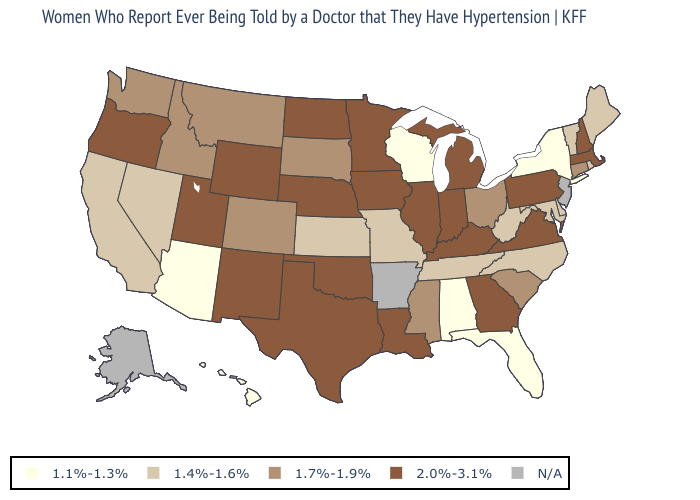What is the lowest value in the South?
Keep it brief. 1.1%-1.3%. Name the states that have a value in the range 1.7%-1.9%?
Concise answer only. Colorado, Connecticut, Idaho, Mississippi, Montana, Ohio, South Carolina, South Dakota, Washington. How many symbols are there in the legend?
Give a very brief answer. 5. Name the states that have a value in the range 2.0%-3.1%?
Answer briefly. Georgia, Illinois, Indiana, Iowa, Kentucky, Louisiana, Massachusetts, Michigan, Minnesota, Nebraska, New Hampshire, New Mexico, North Dakota, Oklahoma, Oregon, Pennsylvania, Texas, Utah, Virginia, Wyoming. What is the value of Vermont?
Be succinct. 1.4%-1.6%. What is the value of New Hampshire?
Concise answer only. 2.0%-3.1%. What is the lowest value in the USA?
Write a very short answer. 1.1%-1.3%. What is the value of California?
Answer briefly. 1.4%-1.6%. What is the lowest value in the USA?
Concise answer only. 1.1%-1.3%. Name the states that have a value in the range 1.7%-1.9%?
Answer briefly. Colorado, Connecticut, Idaho, Mississippi, Montana, Ohio, South Carolina, South Dakota, Washington. Name the states that have a value in the range 1.1%-1.3%?
Quick response, please. Alabama, Arizona, Florida, Hawaii, New York, Wisconsin. Name the states that have a value in the range N/A?
Be succinct. Alaska, Arkansas, New Jersey. Which states have the lowest value in the USA?
Keep it brief. Alabama, Arizona, Florida, Hawaii, New York, Wisconsin. Among the states that border Colorado , does Kansas have the highest value?
Write a very short answer. No. 